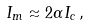<formula> <loc_0><loc_0><loc_500><loc_500>I _ { m } \approx 2 \alpha I _ { c } \, ,</formula> 